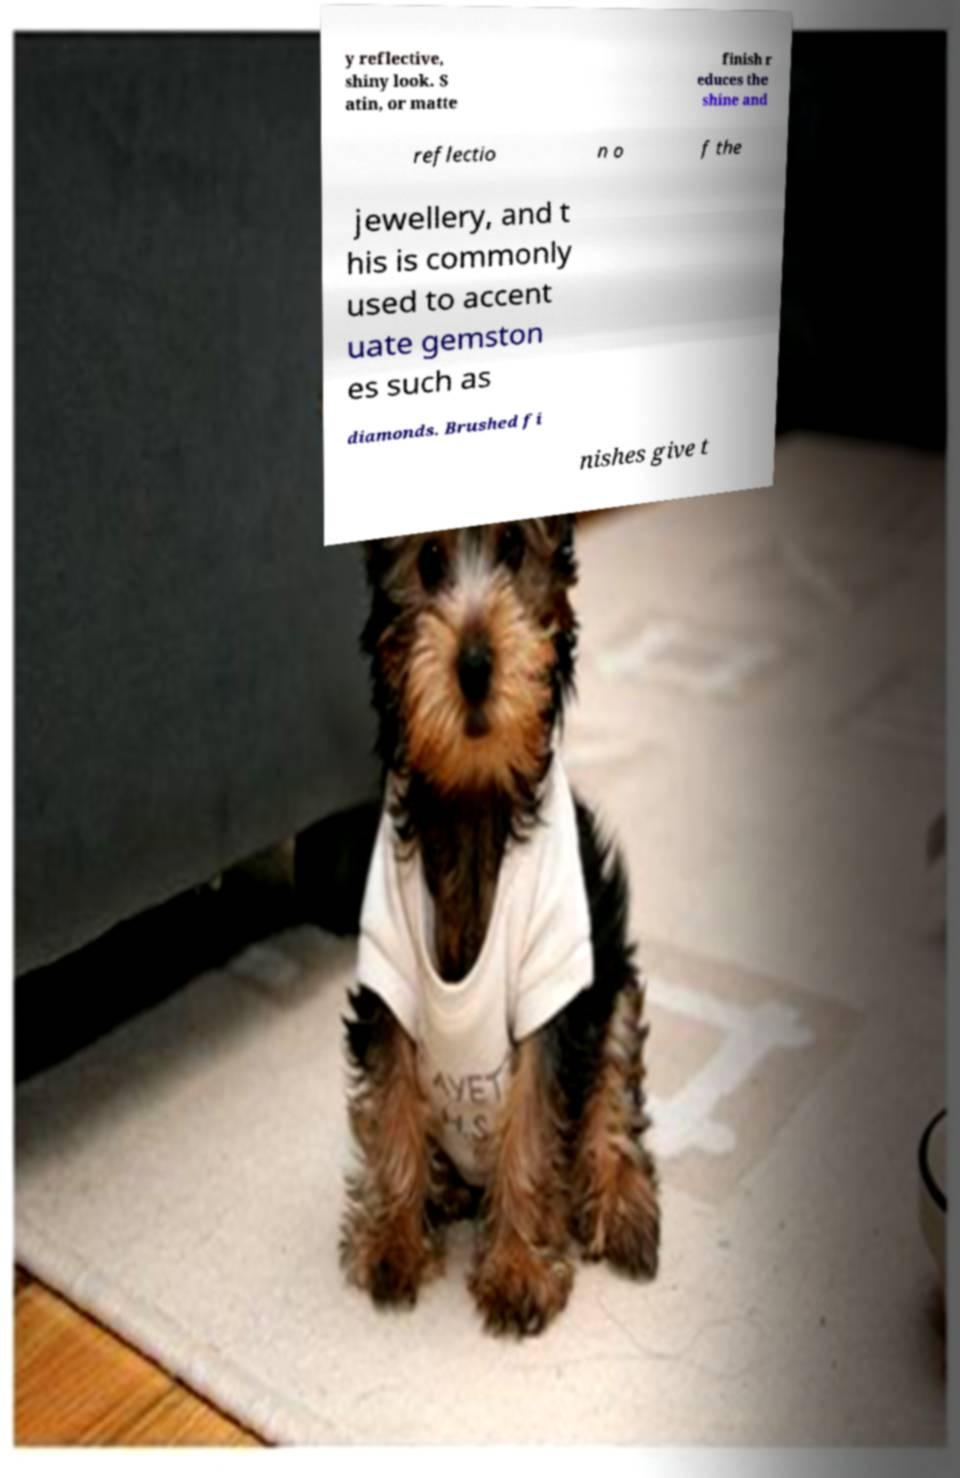Please identify and transcribe the text found in this image. y reflective, shiny look. S atin, or matte finish r educes the shine and reflectio n o f the jewellery, and t his is commonly used to accent uate gemston es such as diamonds. Brushed fi nishes give t 